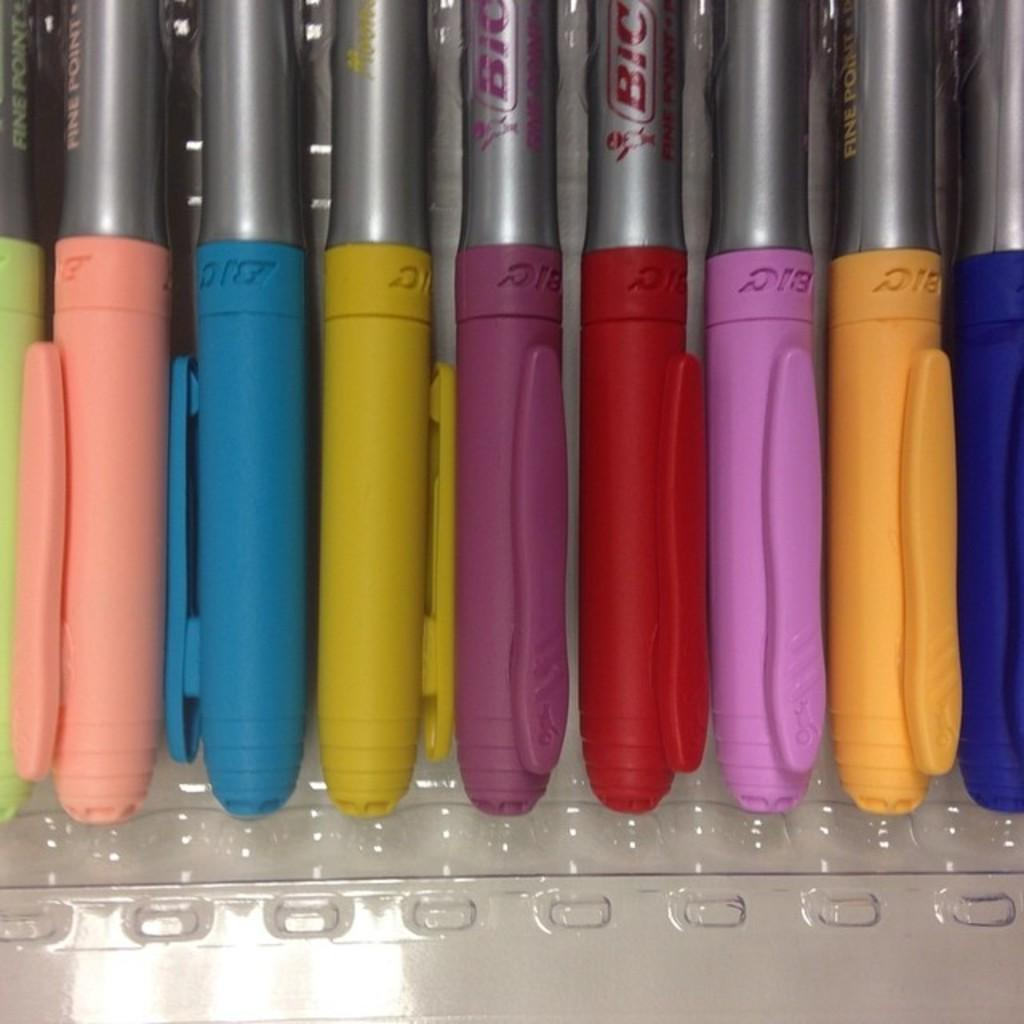What object can be seen in the image? There is a box in the image. What is inside the box? The box contains pens. What type of pump is being used during the meeting in the image? There is no pump or meeting present in the image; it only features a box containing pens. 